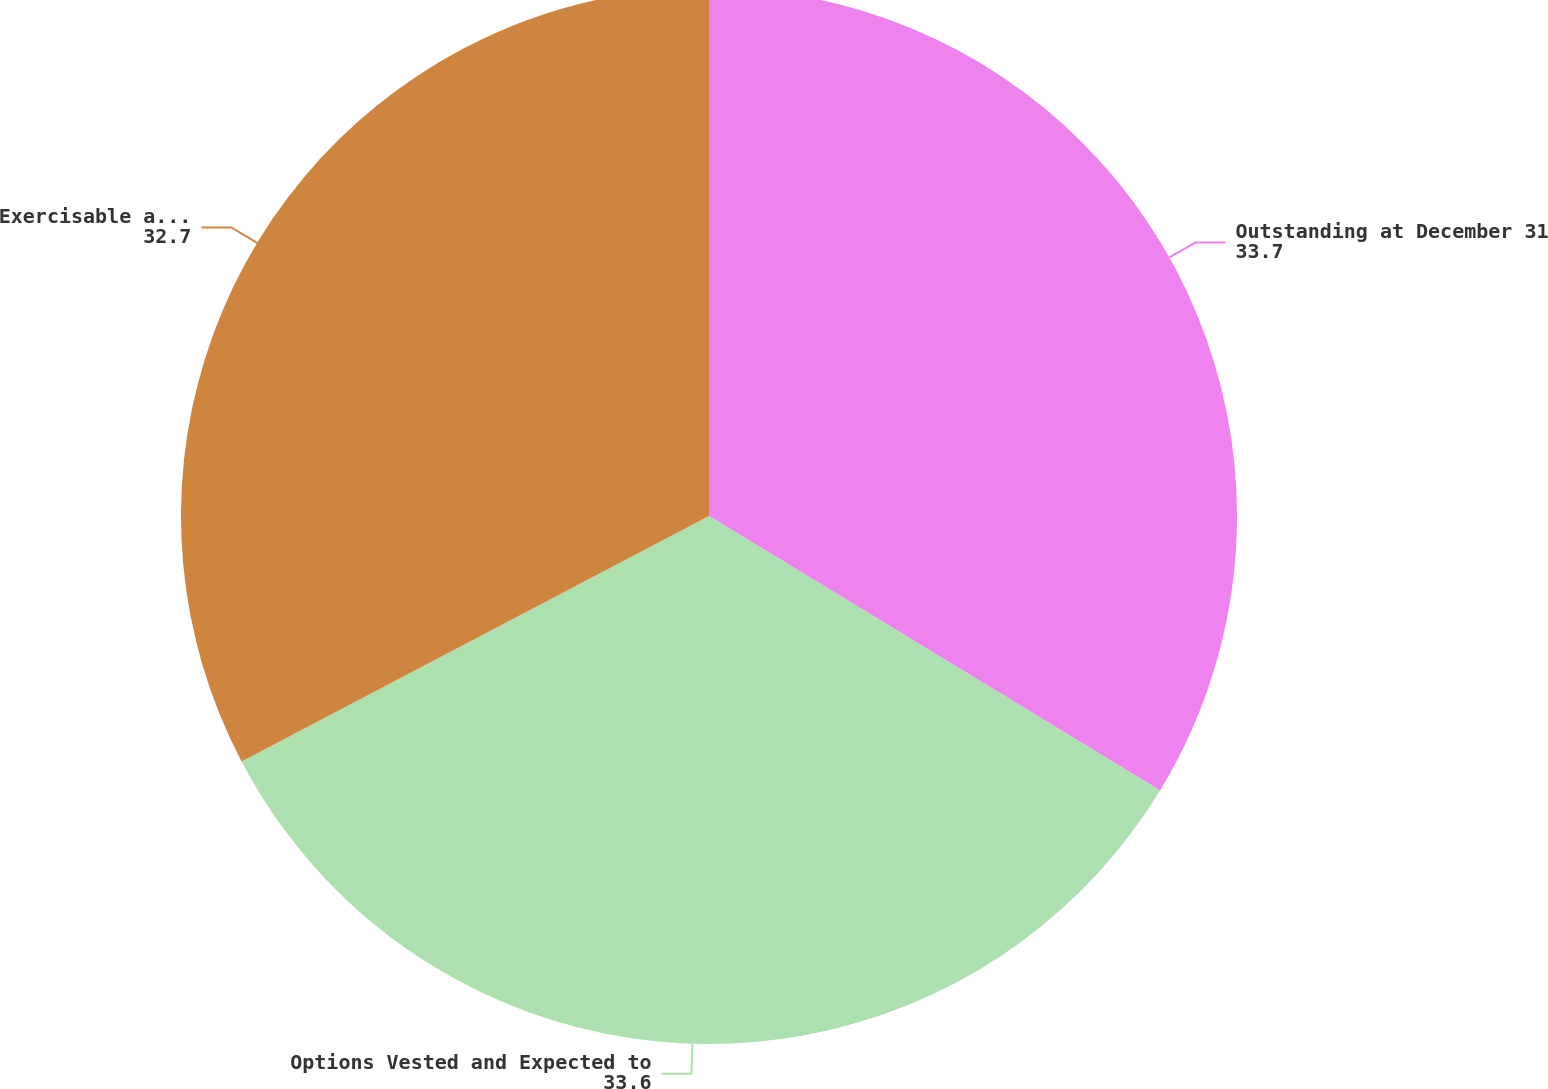Convert chart. <chart><loc_0><loc_0><loc_500><loc_500><pie_chart><fcel>Outstanding at December 31<fcel>Options Vested and Expected to<fcel>Exercisable at December 31<nl><fcel>33.7%<fcel>33.6%<fcel>32.7%<nl></chart> 